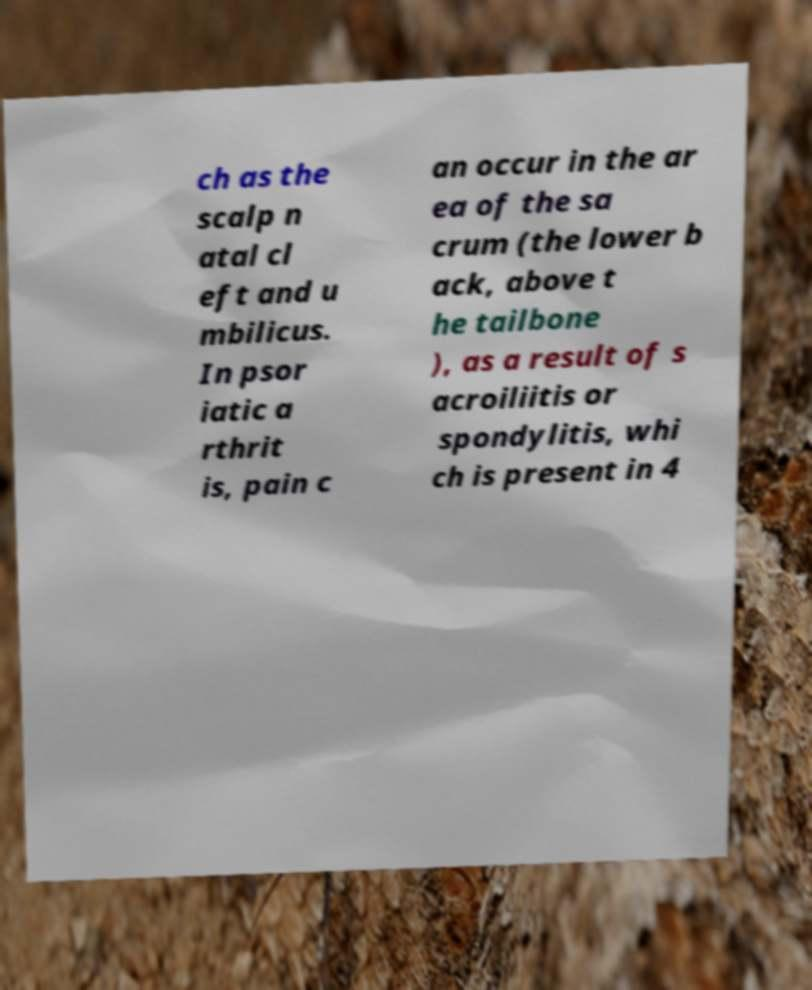Could you assist in decoding the text presented in this image and type it out clearly? ch as the scalp n atal cl eft and u mbilicus. In psor iatic a rthrit is, pain c an occur in the ar ea of the sa crum (the lower b ack, above t he tailbone ), as a result of s acroiliitis or spondylitis, whi ch is present in 4 